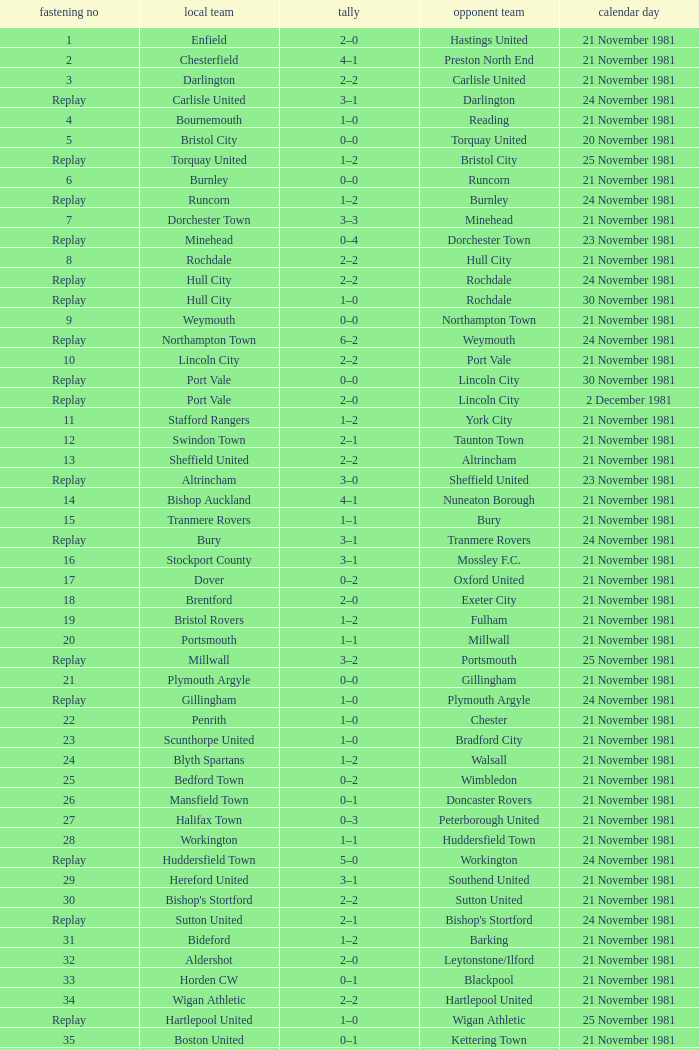What is enfield's tie number? 1.0. 